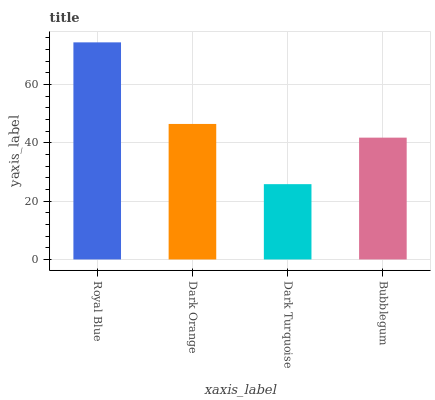Is Dark Turquoise the minimum?
Answer yes or no. Yes. Is Royal Blue the maximum?
Answer yes or no. Yes. Is Dark Orange the minimum?
Answer yes or no. No. Is Dark Orange the maximum?
Answer yes or no. No. Is Royal Blue greater than Dark Orange?
Answer yes or no. Yes. Is Dark Orange less than Royal Blue?
Answer yes or no. Yes. Is Dark Orange greater than Royal Blue?
Answer yes or no. No. Is Royal Blue less than Dark Orange?
Answer yes or no. No. Is Dark Orange the high median?
Answer yes or no. Yes. Is Bubblegum the low median?
Answer yes or no. Yes. Is Dark Turquoise the high median?
Answer yes or no. No. Is Dark Turquoise the low median?
Answer yes or no. No. 